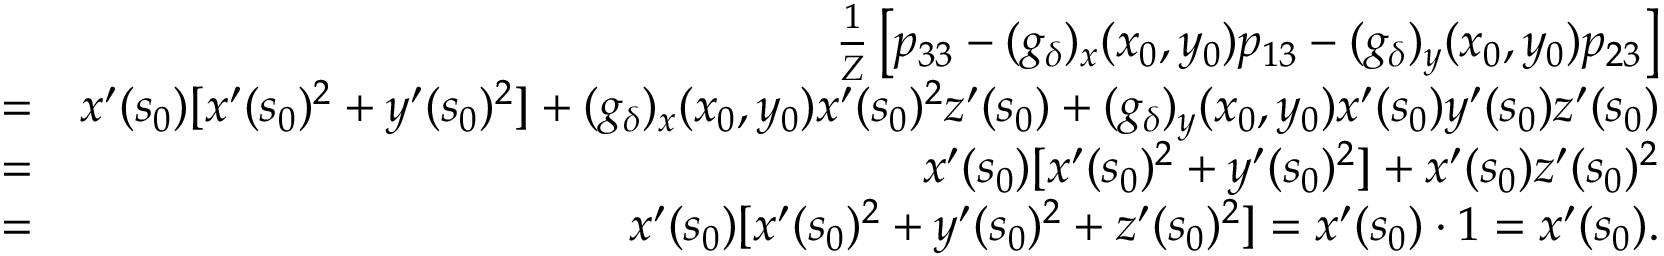Convert formula to latex. <formula><loc_0><loc_0><loc_500><loc_500>\begin{array} { r l r } & { \frac { 1 } { Z } \left [ p _ { 3 3 } - ( g _ { \delta } ) _ { x } ( x _ { 0 } , y _ { 0 } ) p _ { 1 3 } - ( g _ { \delta } ) _ { y } ( x _ { 0 } , y _ { 0 } ) p _ { 2 3 } \right ] } \\ & { = } & { x ^ { \prime } ( s _ { 0 } ) [ x ^ { \prime } ( s _ { 0 } ) ^ { 2 } + y ^ { \prime } ( s _ { 0 } ) ^ { 2 } ] + ( g _ { \delta } ) _ { x } ( x _ { 0 } , y _ { 0 } ) x ^ { \prime } ( s _ { 0 } ) ^ { 2 } z ^ { \prime } ( s _ { 0 } ) + ( g _ { \delta } ) _ { y } ( x _ { 0 } , y _ { 0 } ) x ^ { \prime } ( s _ { 0 } ) y ^ { \prime } ( s _ { 0 } ) z ^ { \prime } ( s _ { 0 } ) } \\ & { = } & { x ^ { \prime } ( s _ { 0 } ) [ x ^ { \prime } ( s _ { 0 } ) ^ { 2 } + y ^ { \prime } ( s _ { 0 } ) ^ { 2 } ] + x ^ { \prime } ( s _ { 0 } ) z ^ { \prime } ( s _ { 0 } ) ^ { 2 } } \\ & { = } & { x ^ { \prime } ( s _ { 0 } ) [ x ^ { \prime } ( s _ { 0 } ) ^ { 2 } + y ^ { \prime } ( s _ { 0 } ) ^ { 2 } + z ^ { \prime } ( s _ { 0 } ) ^ { 2 } ] = x ^ { \prime } ( s _ { 0 } ) \cdot 1 = x ^ { \prime } ( s _ { 0 } ) . } \end{array}</formula> 